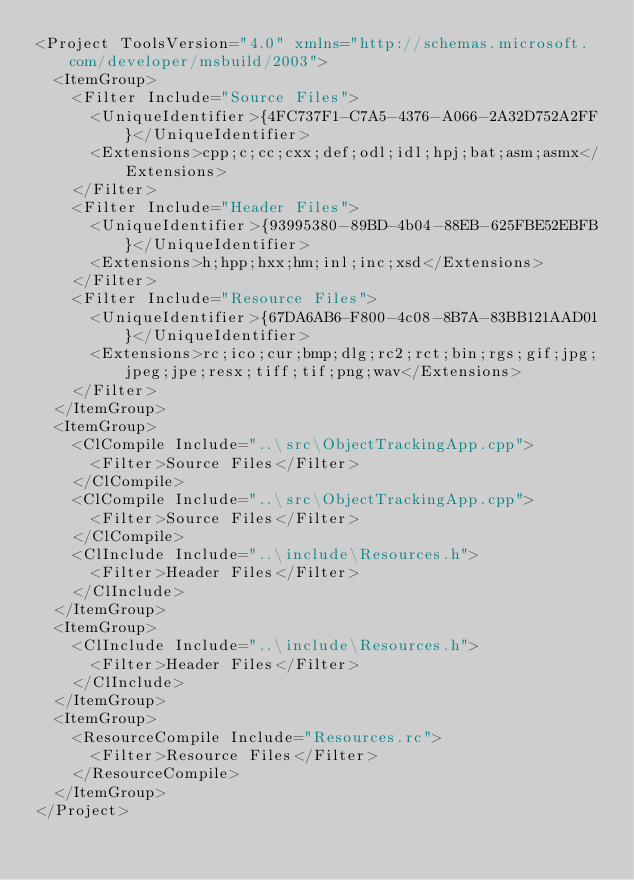Convert code to text. <code><loc_0><loc_0><loc_500><loc_500><_XML_><Project ToolsVersion="4.0" xmlns="http://schemas.microsoft.com/developer/msbuild/2003">
  <ItemGroup>
    <Filter Include="Source Files">
      <UniqueIdentifier>{4FC737F1-C7A5-4376-A066-2A32D752A2FF}</UniqueIdentifier>
      <Extensions>cpp;c;cc;cxx;def;odl;idl;hpj;bat;asm;asmx</Extensions>
    </Filter>
    <Filter Include="Header Files">
      <UniqueIdentifier>{93995380-89BD-4b04-88EB-625FBE52EBFB}</UniqueIdentifier>
      <Extensions>h;hpp;hxx;hm;inl;inc;xsd</Extensions>
    </Filter>
    <Filter Include="Resource Files">
      <UniqueIdentifier>{67DA6AB6-F800-4c08-8B7A-83BB121AAD01}</UniqueIdentifier>
      <Extensions>rc;ico;cur;bmp;dlg;rc2;rct;bin;rgs;gif;jpg;jpeg;jpe;resx;tiff;tif;png;wav</Extensions>
    </Filter>
  </ItemGroup>
  <ItemGroup>
    <ClCompile Include="..\src\ObjectTrackingApp.cpp">
      <Filter>Source Files</Filter>
    </ClCompile>
    <ClCompile Include="..\src\ObjectTrackingApp.cpp">
      <Filter>Source Files</Filter>
    </ClCompile>
    <ClInclude Include="..\include\Resources.h">
      <Filter>Header Files</Filter>
    </ClInclude>
  </ItemGroup>
  <ItemGroup>
    <ClInclude Include="..\include\Resources.h">
      <Filter>Header Files</Filter>
    </ClInclude>
  </ItemGroup>
  <ItemGroup>
    <ResourceCompile Include="Resources.rc">
      <Filter>Resource Files</Filter>
    </ResourceCompile>
  </ItemGroup>
</Project>
</code> 